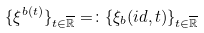<formula> <loc_0><loc_0><loc_500><loc_500>\{ \xi ^ { b ( t ) } \} _ { t \in \overline { \mathbb { R } } } = \colon \{ \xi _ { b } ( i d , t ) \} _ { t \in \overline { \mathbb { R } } }</formula> 